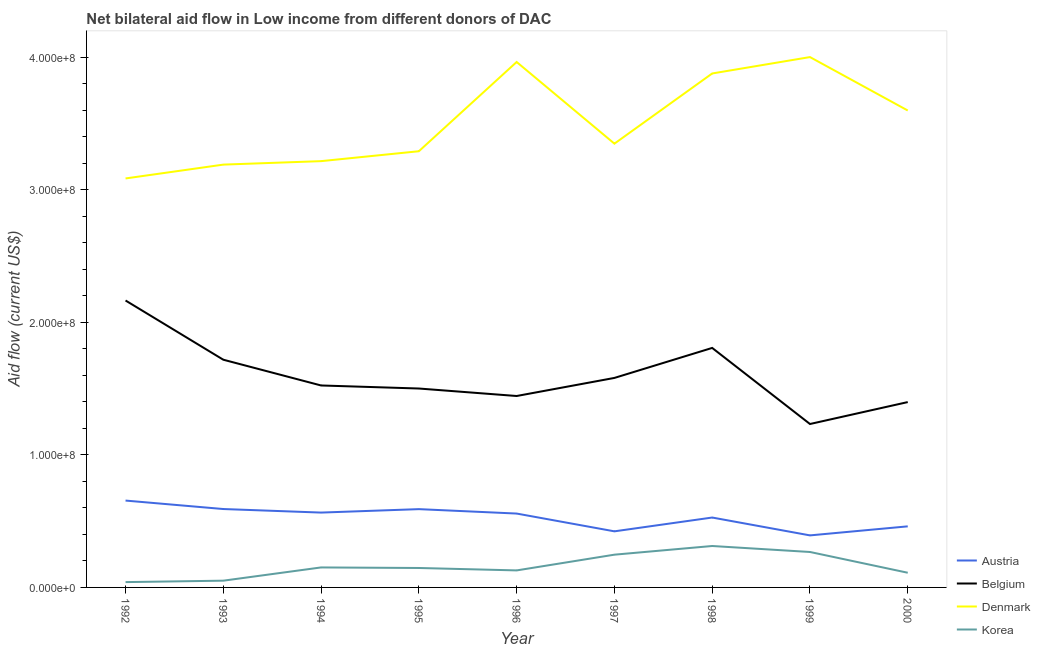Does the line corresponding to amount of aid given by belgium intersect with the line corresponding to amount of aid given by korea?
Keep it short and to the point. No. What is the amount of aid given by austria in 1994?
Give a very brief answer. 5.64e+07. Across all years, what is the maximum amount of aid given by korea?
Give a very brief answer. 3.12e+07. Across all years, what is the minimum amount of aid given by denmark?
Your answer should be compact. 3.08e+08. In which year was the amount of aid given by austria maximum?
Offer a very short reply. 1992. What is the total amount of aid given by belgium in the graph?
Your response must be concise. 1.44e+09. What is the difference between the amount of aid given by korea in 1994 and that in 1995?
Provide a succinct answer. 4.20e+05. What is the difference between the amount of aid given by korea in 1993 and the amount of aid given by austria in 1996?
Ensure brevity in your answer.  -5.06e+07. What is the average amount of aid given by belgium per year?
Ensure brevity in your answer.  1.60e+08. In the year 1996, what is the difference between the amount of aid given by belgium and amount of aid given by denmark?
Your response must be concise. -2.52e+08. What is the ratio of the amount of aid given by denmark in 1992 to that in 2000?
Offer a very short reply. 0.86. What is the difference between the highest and the second highest amount of aid given by denmark?
Your response must be concise. 3.70e+06. What is the difference between the highest and the lowest amount of aid given by belgium?
Ensure brevity in your answer.  9.32e+07. Is the sum of the amount of aid given by denmark in 1992 and 1999 greater than the maximum amount of aid given by belgium across all years?
Provide a succinct answer. Yes. Is it the case that in every year, the sum of the amount of aid given by korea and amount of aid given by austria is greater than the sum of amount of aid given by belgium and amount of aid given by denmark?
Ensure brevity in your answer.  No. Does the amount of aid given by austria monotonically increase over the years?
Provide a succinct answer. No. Is the amount of aid given by korea strictly less than the amount of aid given by denmark over the years?
Offer a very short reply. Yes. Are the values on the major ticks of Y-axis written in scientific E-notation?
Ensure brevity in your answer.  Yes. Where does the legend appear in the graph?
Provide a short and direct response. Bottom right. How many legend labels are there?
Offer a very short reply. 4. How are the legend labels stacked?
Ensure brevity in your answer.  Vertical. What is the title of the graph?
Your response must be concise. Net bilateral aid flow in Low income from different donors of DAC. Does "Tracking ability" appear as one of the legend labels in the graph?
Give a very brief answer. No. What is the label or title of the X-axis?
Your answer should be compact. Year. What is the Aid flow (current US$) of Austria in 1992?
Give a very brief answer. 6.55e+07. What is the Aid flow (current US$) in Belgium in 1992?
Your answer should be very brief. 2.16e+08. What is the Aid flow (current US$) in Denmark in 1992?
Offer a very short reply. 3.08e+08. What is the Aid flow (current US$) of Korea in 1992?
Provide a short and direct response. 4.01e+06. What is the Aid flow (current US$) of Austria in 1993?
Your answer should be compact. 5.91e+07. What is the Aid flow (current US$) in Belgium in 1993?
Give a very brief answer. 1.72e+08. What is the Aid flow (current US$) of Denmark in 1993?
Your answer should be very brief. 3.19e+08. What is the Aid flow (current US$) of Korea in 1993?
Ensure brevity in your answer.  5.09e+06. What is the Aid flow (current US$) in Austria in 1994?
Your answer should be compact. 5.64e+07. What is the Aid flow (current US$) in Belgium in 1994?
Make the answer very short. 1.52e+08. What is the Aid flow (current US$) in Denmark in 1994?
Give a very brief answer. 3.21e+08. What is the Aid flow (current US$) in Korea in 1994?
Provide a short and direct response. 1.51e+07. What is the Aid flow (current US$) in Austria in 1995?
Your response must be concise. 5.90e+07. What is the Aid flow (current US$) of Belgium in 1995?
Offer a terse response. 1.50e+08. What is the Aid flow (current US$) of Denmark in 1995?
Give a very brief answer. 3.29e+08. What is the Aid flow (current US$) in Korea in 1995?
Give a very brief answer. 1.47e+07. What is the Aid flow (current US$) of Austria in 1996?
Offer a terse response. 5.57e+07. What is the Aid flow (current US$) of Belgium in 1996?
Your answer should be compact. 1.44e+08. What is the Aid flow (current US$) of Denmark in 1996?
Provide a succinct answer. 3.96e+08. What is the Aid flow (current US$) of Korea in 1996?
Make the answer very short. 1.28e+07. What is the Aid flow (current US$) in Austria in 1997?
Your answer should be very brief. 4.23e+07. What is the Aid flow (current US$) of Belgium in 1997?
Offer a very short reply. 1.58e+08. What is the Aid flow (current US$) of Denmark in 1997?
Ensure brevity in your answer.  3.35e+08. What is the Aid flow (current US$) in Korea in 1997?
Your response must be concise. 2.47e+07. What is the Aid flow (current US$) in Austria in 1998?
Provide a short and direct response. 5.27e+07. What is the Aid flow (current US$) in Belgium in 1998?
Offer a very short reply. 1.81e+08. What is the Aid flow (current US$) in Denmark in 1998?
Your answer should be very brief. 3.88e+08. What is the Aid flow (current US$) of Korea in 1998?
Your response must be concise. 3.12e+07. What is the Aid flow (current US$) in Austria in 1999?
Offer a terse response. 3.92e+07. What is the Aid flow (current US$) of Belgium in 1999?
Make the answer very short. 1.23e+08. What is the Aid flow (current US$) in Denmark in 1999?
Your response must be concise. 4.00e+08. What is the Aid flow (current US$) of Korea in 1999?
Give a very brief answer. 2.67e+07. What is the Aid flow (current US$) of Austria in 2000?
Give a very brief answer. 4.61e+07. What is the Aid flow (current US$) in Belgium in 2000?
Your response must be concise. 1.40e+08. What is the Aid flow (current US$) of Denmark in 2000?
Ensure brevity in your answer.  3.60e+08. What is the Aid flow (current US$) of Korea in 2000?
Your response must be concise. 1.11e+07. Across all years, what is the maximum Aid flow (current US$) of Austria?
Provide a short and direct response. 6.55e+07. Across all years, what is the maximum Aid flow (current US$) in Belgium?
Give a very brief answer. 2.16e+08. Across all years, what is the maximum Aid flow (current US$) of Denmark?
Offer a very short reply. 4.00e+08. Across all years, what is the maximum Aid flow (current US$) of Korea?
Your response must be concise. 3.12e+07. Across all years, what is the minimum Aid flow (current US$) of Austria?
Give a very brief answer. 3.92e+07. Across all years, what is the minimum Aid flow (current US$) in Belgium?
Give a very brief answer. 1.23e+08. Across all years, what is the minimum Aid flow (current US$) in Denmark?
Offer a terse response. 3.08e+08. Across all years, what is the minimum Aid flow (current US$) in Korea?
Offer a terse response. 4.01e+06. What is the total Aid flow (current US$) of Austria in the graph?
Your answer should be very brief. 4.76e+08. What is the total Aid flow (current US$) in Belgium in the graph?
Your answer should be compact. 1.44e+09. What is the total Aid flow (current US$) in Denmark in the graph?
Provide a succinct answer. 3.16e+09. What is the total Aid flow (current US$) in Korea in the graph?
Make the answer very short. 1.45e+08. What is the difference between the Aid flow (current US$) of Austria in 1992 and that in 1993?
Give a very brief answer. 6.38e+06. What is the difference between the Aid flow (current US$) of Belgium in 1992 and that in 1993?
Give a very brief answer. 4.47e+07. What is the difference between the Aid flow (current US$) of Denmark in 1992 and that in 1993?
Make the answer very short. -1.04e+07. What is the difference between the Aid flow (current US$) of Korea in 1992 and that in 1993?
Make the answer very short. -1.08e+06. What is the difference between the Aid flow (current US$) of Austria in 1992 and that in 1994?
Your answer should be compact. 9.05e+06. What is the difference between the Aid flow (current US$) in Belgium in 1992 and that in 1994?
Provide a short and direct response. 6.41e+07. What is the difference between the Aid flow (current US$) in Denmark in 1992 and that in 1994?
Offer a terse response. -1.30e+07. What is the difference between the Aid flow (current US$) of Korea in 1992 and that in 1994?
Offer a very short reply. -1.11e+07. What is the difference between the Aid flow (current US$) in Austria in 1992 and that in 1995?
Offer a terse response. 6.46e+06. What is the difference between the Aid flow (current US$) of Belgium in 1992 and that in 1995?
Provide a succinct answer. 6.64e+07. What is the difference between the Aid flow (current US$) in Denmark in 1992 and that in 1995?
Keep it short and to the point. -2.05e+07. What is the difference between the Aid flow (current US$) of Korea in 1992 and that in 1995?
Make the answer very short. -1.06e+07. What is the difference between the Aid flow (current US$) in Austria in 1992 and that in 1996?
Give a very brief answer. 9.79e+06. What is the difference between the Aid flow (current US$) in Belgium in 1992 and that in 1996?
Offer a terse response. 7.20e+07. What is the difference between the Aid flow (current US$) of Denmark in 1992 and that in 1996?
Your response must be concise. -8.78e+07. What is the difference between the Aid flow (current US$) of Korea in 1992 and that in 1996?
Ensure brevity in your answer.  -8.82e+06. What is the difference between the Aid flow (current US$) of Austria in 1992 and that in 1997?
Your answer should be compact. 2.32e+07. What is the difference between the Aid flow (current US$) of Belgium in 1992 and that in 1997?
Provide a succinct answer. 5.84e+07. What is the difference between the Aid flow (current US$) in Denmark in 1992 and that in 1997?
Your response must be concise. -2.62e+07. What is the difference between the Aid flow (current US$) in Korea in 1992 and that in 1997?
Keep it short and to the point. -2.07e+07. What is the difference between the Aid flow (current US$) in Austria in 1992 and that in 1998?
Your response must be concise. 1.28e+07. What is the difference between the Aid flow (current US$) of Belgium in 1992 and that in 1998?
Keep it short and to the point. 3.58e+07. What is the difference between the Aid flow (current US$) of Denmark in 1992 and that in 1998?
Give a very brief answer. -7.92e+07. What is the difference between the Aid flow (current US$) of Korea in 1992 and that in 1998?
Give a very brief answer. -2.72e+07. What is the difference between the Aid flow (current US$) in Austria in 1992 and that in 1999?
Your response must be concise. 2.63e+07. What is the difference between the Aid flow (current US$) of Belgium in 1992 and that in 1999?
Offer a terse response. 9.32e+07. What is the difference between the Aid flow (current US$) of Denmark in 1992 and that in 1999?
Provide a short and direct response. -9.15e+07. What is the difference between the Aid flow (current US$) in Korea in 1992 and that in 1999?
Make the answer very short. -2.27e+07. What is the difference between the Aid flow (current US$) in Austria in 1992 and that in 2000?
Keep it short and to the point. 1.94e+07. What is the difference between the Aid flow (current US$) of Belgium in 1992 and that in 2000?
Your answer should be very brief. 7.66e+07. What is the difference between the Aid flow (current US$) in Denmark in 1992 and that in 2000?
Provide a succinct answer. -5.12e+07. What is the difference between the Aid flow (current US$) in Korea in 1992 and that in 2000?
Your answer should be very brief. -7.06e+06. What is the difference between the Aid flow (current US$) of Austria in 1993 and that in 1994?
Your answer should be compact. 2.67e+06. What is the difference between the Aid flow (current US$) of Belgium in 1993 and that in 1994?
Offer a terse response. 1.94e+07. What is the difference between the Aid flow (current US$) in Denmark in 1993 and that in 1994?
Provide a succinct answer. -2.62e+06. What is the difference between the Aid flow (current US$) of Korea in 1993 and that in 1994?
Provide a succinct answer. -9.99e+06. What is the difference between the Aid flow (current US$) of Belgium in 1993 and that in 1995?
Offer a very short reply. 2.17e+07. What is the difference between the Aid flow (current US$) of Denmark in 1993 and that in 1995?
Your answer should be compact. -1.01e+07. What is the difference between the Aid flow (current US$) of Korea in 1993 and that in 1995?
Offer a very short reply. -9.57e+06. What is the difference between the Aid flow (current US$) in Austria in 1993 and that in 1996?
Give a very brief answer. 3.41e+06. What is the difference between the Aid flow (current US$) in Belgium in 1993 and that in 1996?
Keep it short and to the point. 2.74e+07. What is the difference between the Aid flow (current US$) in Denmark in 1993 and that in 1996?
Your answer should be very brief. -7.74e+07. What is the difference between the Aid flow (current US$) of Korea in 1993 and that in 1996?
Offer a terse response. -7.74e+06. What is the difference between the Aid flow (current US$) of Austria in 1993 and that in 1997?
Offer a very short reply. 1.68e+07. What is the difference between the Aid flow (current US$) of Belgium in 1993 and that in 1997?
Offer a terse response. 1.37e+07. What is the difference between the Aid flow (current US$) of Denmark in 1993 and that in 1997?
Make the answer very short. -1.58e+07. What is the difference between the Aid flow (current US$) in Korea in 1993 and that in 1997?
Provide a succinct answer. -1.96e+07. What is the difference between the Aid flow (current US$) of Austria in 1993 and that in 1998?
Ensure brevity in your answer.  6.41e+06. What is the difference between the Aid flow (current US$) in Belgium in 1993 and that in 1998?
Offer a very short reply. -8.90e+06. What is the difference between the Aid flow (current US$) in Denmark in 1993 and that in 1998?
Your answer should be very brief. -6.87e+07. What is the difference between the Aid flow (current US$) of Korea in 1993 and that in 1998?
Offer a very short reply. -2.62e+07. What is the difference between the Aid flow (current US$) of Austria in 1993 and that in 1999?
Make the answer very short. 1.99e+07. What is the difference between the Aid flow (current US$) in Belgium in 1993 and that in 1999?
Offer a terse response. 4.85e+07. What is the difference between the Aid flow (current US$) of Denmark in 1993 and that in 1999?
Give a very brief answer. -8.11e+07. What is the difference between the Aid flow (current US$) in Korea in 1993 and that in 1999?
Provide a succinct answer. -2.16e+07. What is the difference between the Aid flow (current US$) of Austria in 1993 and that in 2000?
Make the answer very short. 1.31e+07. What is the difference between the Aid flow (current US$) of Belgium in 1993 and that in 2000?
Provide a short and direct response. 3.20e+07. What is the difference between the Aid flow (current US$) in Denmark in 1993 and that in 2000?
Your answer should be compact. -4.08e+07. What is the difference between the Aid flow (current US$) in Korea in 1993 and that in 2000?
Offer a very short reply. -5.98e+06. What is the difference between the Aid flow (current US$) in Austria in 1994 and that in 1995?
Your answer should be compact. -2.59e+06. What is the difference between the Aid flow (current US$) in Belgium in 1994 and that in 1995?
Offer a terse response. 2.29e+06. What is the difference between the Aid flow (current US$) of Denmark in 1994 and that in 1995?
Give a very brief answer. -7.47e+06. What is the difference between the Aid flow (current US$) in Austria in 1994 and that in 1996?
Make the answer very short. 7.40e+05. What is the difference between the Aid flow (current US$) of Belgium in 1994 and that in 1996?
Offer a very short reply. 7.94e+06. What is the difference between the Aid flow (current US$) in Denmark in 1994 and that in 1996?
Your response must be concise. -7.48e+07. What is the difference between the Aid flow (current US$) of Korea in 1994 and that in 1996?
Give a very brief answer. 2.25e+06. What is the difference between the Aid flow (current US$) in Austria in 1994 and that in 1997?
Your response must be concise. 1.42e+07. What is the difference between the Aid flow (current US$) of Belgium in 1994 and that in 1997?
Make the answer very short. -5.70e+06. What is the difference between the Aid flow (current US$) in Denmark in 1994 and that in 1997?
Your answer should be compact. -1.32e+07. What is the difference between the Aid flow (current US$) in Korea in 1994 and that in 1997?
Your response must be concise. -9.62e+06. What is the difference between the Aid flow (current US$) of Austria in 1994 and that in 1998?
Provide a short and direct response. 3.74e+06. What is the difference between the Aid flow (current US$) of Belgium in 1994 and that in 1998?
Your answer should be compact. -2.83e+07. What is the difference between the Aid flow (current US$) of Denmark in 1994 and that in 1998?
Make the answer very short. -6.61e+07. What is the difference between the Aid flow (current US$) of Korea in 1994 and that in 1998?
Your answer should be compact. -1.62e+07. What is the difference between the Aid flow (current US$) of Austria in 1994 and that in 1999?
Keep it short and to the point. 1.72e+07. What is the difference between the Aid flow (current US$) in Belgium in 1994 and that in 1999?
Offer a terse response. 2.91e+07. What is the difference between the Aid flow (current US$) of Denmark in 1994 and that in 1999?
Your answer should be compact. -7.85e+07. What is the difference between the Aid flow (current US$) of Korea in 1994 and that in 1999?
Your response must be concise. -1.16e+07. What is the difference between the Aid flow (current US$) in Austria in 1994 and that in 2000?
Give a very brief answer. 1.04e+07. What is the difference between the Aid flow (current US$) in Belgium in 1994 and that in 2000?
Offer a very short reply. 1.25e+07. What is the difference between the Aid flow (current US$) in Denmark in 1994 and that in 2000?
Offer a terse response. -3.82e+07. What is the difference between the Aid flow (current US$) in Korea in 1994 and that in 2000?
Keep it short and to the point. 4.01e+06. What is the difference between the Aid flow (current US$) in Austria in 1995 and that in 1996?
Give a very brief answer. 3.33e+06. What is the difference between the Aid flow (current US$) in Belgium in 1995 and that in 1996?
Keep it short and to the point. 5.65e+06. What is the difference between the Aid flow (current US$) of Denmark in 1995 and that in 1996?
Provide a short and direct response. -6.73e+07. What is the difference between the Aid flow (current US$) of Korea in 1995 and that in 1996?
Provide a succinct answer. 1.83e+06. What is the difference between the Aid flow (current US$) of Austria in 1995 and that in 1997?
Your answer should be very brief. 1.67e+07. What is the difference between the Aid flow (current US$) of Belgium in 1995 and that in 1997?
Provide a succinct answer. -7.99e+06. What is the difference between the Aid flow (current US$) in Denmark in 1995 and that in 1997?
Provide a succinct answer. -5.72e+06. What is the difference between the Aid flow (current US$) in Korea in 1995 and that in 1997?
Ensure brevity in your answer.  -1.00e+07. What is the difference between the Aid flow (current US$) of Austria in 1995 and that in 1998?
Provide a short and direct response. 6.33e+06. What is the difference between the Aid flow (current US$) of Belgium in 1995 and that in 1998?
Make the answer very short. -3.06e+07. What is the difference between the Aid flow (current US$) in Denmark in 1995 and that in 1998?
Ensure brevity in your answer.  -5.86e+07. What is the difference between the Aid flow (current US$) of Korea in 1995 and that in 1998?
Give a very brief answer. -1.66e+07. What is the difference between the Aid flow (current US$) of Austria in 1995 and that in 1999?
Offer a terse response. 1.98e+07. What is the difference between the Aid flow (current US$) of Belgium in 1995 and that in 1999?
Give a very brief answer. 2.68e+07. What is the difference between the Aid flow (current US$) in Denmark in 1995 and that in 1999?
Your answer should be compact. -7.10e+07. What is the difference between the Aid flow (current US$) in Korea in 1995 and that in 1999?
Provide a short and direct response. -1.21e+07. What is the difference between the Aid flow (current US$) in Austria in 1995 and that in 2000?
Provide a succinct answer. 1.30e+07. What is the difference between the Aid flow (current US$) in Belgium in 1995 and that in 2000?
Keep it short and to the point. 1.02e+07. What is the difference between the Aid flow (current US$) in Denmark in 1995 and that in 2000?
Your answer should be compact. -3.07e+07. What is the difference between the Aid flow (current US$) of Korea in 1995 and that in 2000?
Make the answer very short. 3.59e+06. What is the difference between the Aid flow (current US$) in Austria in 1996 and that in 1997?
Give a very brief answer. 1.34e+07. What is the difference between the Aid flow (current US$) of Belgium in 1996 and that in 1997?
Make the answer very short. -1.36e+07. What is the difference between the Aid flow (current US$) of Denmark in 1996 and that in 1997?
Offer a very short reply. 6.16e+07. What is the difference between the Aid flow (current US$) in Korea in 1996 and that in 1997?
Your answer should be compact. -1.19e+07. What is the difference between the Aid flow (current US$) of Belgium in 1996 and that in 1998?
Your response must be concise. -3.63e+07. What is the difference between the Aid flow (current US$) of Denmark in 1996 and that in 1998?
Provide a short and direct response. 8.66e+06. What is the difference between the Aid flow (current US$) of Korea in 1996 and that in 1998?
Keep it short and to the point. -1.84e+07. What is the difference between the Aid flow (current US$) of Austria in 1996 and that in 1999?
Keep it short and to the point. 1.65e+07. What is the difference between the Aid flow (current US$) in Belgium in 1996 and that in 1999?
Offer a very short reply. 2.11e+07. What is the difference between the Aid flow (current US$) in Denmark in 1996 and that in 1999?
Keep it short and to the point. -3.70e+06. What is the difference between the Aid flow (current US$) of Korea in 1996 and that in 1999?
Make the answer very short. -1.39e+07. What is the difference between the Aid flow (current US$) in Austria in 1996 and that in 2000?
Provide a succinct answer. 9.65e+06. What is the difference between the Aid flow (current US$) of Belgium in 1996 and that in 2000?
Offer a terse response. 4.59e+06. What is the difference between the Aid flow (current US$) in Denmark in 1996 and that in 2000?
Your answer should be very brief. 3.66e+07. What is the difference between the Aid flow (current US$) of Korea in 1996 and that in 2000?
Keep it short and to the point. 1.76e+06. What is the difference between the Aid flow (current US$) in Austria in 1997 and that in 1998?
Offer a terse response. -1.04e+07. What is the difference between the Aid flow (current US$) of Belgium in 1997 and that in 1998?
Provide a short and direct response. -2.26e+07. What is the difference between the Aid flow (current US$) of Denmark in 1997 and that in 1998?
Your answer should be very brief. -5.29e+07. What is the difference between the Aid flow (current US$) in Korea in 1997 and that in 1998?
Offer a terse response. -6.54e+06. What is the difference between the Aid flow (current US$) in Austria in 1997 and that in 1999?
Provide a succinct answer. 3.06e+06. What is the difference between the Aid flow (current US$) of Belgium in 1997 and that in 1999?
Make the answer very short. 3.48e+07. What is the difference between the Aid flow (current US$) in Denmark in 1997 and that in 1999?
Provide a succinct answer. -6.53e+07. What is the difference between the Aid flow (current US$) in Korea in 1997 and that in 1999?
Offer a very short reply. -2.03e+06. What is the difference between the Aid flow (current US$) in Austria in 1997 and that in 2000?
Keep it short and to the point. -3.76e+06. What is the difference between the Aid flow (current US$) of Belgium in 1997 and that in 2000?
Provide a succinct answer. 1.82e+07. What is the difference between the Aid flow (current US$) of Denmark in 1997 and that in 2000?
Your answer should be compact. -2.50e+07. What is the difference between the Aid flow (current US$) of Korea in 1997 and that in 2000?
Give a very brief answer. 1.36e+07. What is the difference between the Aid flow (current US$) in Austria in 1998 and that in 1999?
Make the answer very short. 1.35e+07. What is the difference between the Aid flow (current US$) of Belgium in 1998 and that in 1999?
Ensure brevity in your answer.  5.74e+07. What is the difference between the Aid flow (current US$) of Denmark in 1998 and that in 1999?
Give a very brief answer. -1.24e+07. What is the difference between the Aid flow (current US$) of Korea in 1998 and that in 1999?
Give a very brief answer. 4.51e+06. What is the difference between the Aid flow (current US$) of Austria in 1998 and that in 2000?
Offer a very short reply. 6.65e+06. What is the difference between the Aid flow (current US$) of Belgium in 1998 and that in 2000?
Your answer should be compact. 4.08e+07. What is the difference between the Aid flow (current US$) of Denmark in 1998 and that in 2000?
Provide a short and direct response. 2.79e+07. What is the difference between the Aid flow (current US$) of Korea in 1998 and that in 2000?
Give a very brief answer. 2.02e+07. What is the difference between the Aid flow (current US$) in Austria in 1999 and that in 2000?
Offer a very short reply. -6.82e+06. What is the difference between the Aid flow (current US$) of Belgium in 1999 and that in 2000?
Offer a terse response. -1.65e+07. What is the difference between the Aid flow (current US$) in Denmark in 1999 and that in 2000?
Your answer should be compact. 4.03e+07. What is the difference between the Aid flow (current US$) of Korea in 1999 and that in 2000?
Offer a terse response. 1.57e+07. What is the difference between the Aid flow (current US$) of Austria in 1992 and the Aid flow (current US$) of Belgium in 1993?
Keep it short and to the point. -1.06e+08. What is the difference between the Aid flow (current US$) in Austria in 1992 and the Aid flow (current US$) in Denmark in 1993?
Keep it short and to the point. -2.53e+08. What is the difference between the Aid flow (current US$) in Austria in 1992 and the Aid flow (current US$) in Korea in 1993?
Give a very brief answer. 6.04e+07. What is the difference between the Aid flow (current US$) in Belgium in 1992 and the Aid flow (current US$) in Denmark in 1993?
Offer a very short reply. -1.02e+08. What is the difference between the Aid flow (current US$) in Belgium in 1992 and the Aid flow (current US$) in Korea in 1993?
Make the answer very short. 2.11e+08. What is the difference between the Aid flow (current US$) of Denmark in 1992 and the Aid flow (current US$) of Korea in 1993?
Provide a succinct answer. 3.03e+08. What is the difference between the Aid flow (current US$) in Austria in 1992 and the Aid flow (current US$) in Belgium in 1994?
Your answer should be compact. -8.68e+07. What is the difference between the Aid flow (current US$) of Austria in 1992 and the Aid flow (current US$) of Denmark in 1994?
Keep it short and to the point. -2.56e+08. What is the difference between the Aid flow (current US$) of Austria in 1992 and the Aid flow (current US$) of Korea in 1994?
Provide a short and direct response. 5.04e+07. What is the difference between the Aid flow (current US$) of Belgium in 1992 and the Aid flow (current US$) of Denmark in 1994?
Keep it short and to the point. -1.05e+08. What is the difference between the Aid flow (current US$) in Belgium in 1992 and the Aid flow (current US$) in Korea in 1994?
Provide a succinct answer. 2.01e+08. What is the difference between the Aid flow (current US$) in Denmark in 1992 and the Aid flow (current US$) in Korea in 1994?
Ensure brevity in your answer.  2.93e+08. What is the difference between the Aid flow (current US$) in Austria in 1992 and the Aid flow (current US$) in Belgium in 1995?
Keep it short and to the point. -8.45e+07. What is the difference between the Aid flow (current US$) of Austria in 1992 and the Aid flow (current US$) of Denmark in 1995?
Your response must be concise. -2.63e+08. What is the difference between the Aid flow (current US$) of Austria in 1992 and the Aid flow (current US$) of Korea in 1995?
Ensure brevity in your answer.  5.08e+07. What is the difference between the Aid flow (current US$) of Belgium in 1992 and the Aid flow (current US$) of Denmark in 1995?
Keep it short and to the point. -1.13e+08. What is the difference between the Aid flow (current US$) in Belgium in 1992 and the Aid flow (current US$) in Korea in 1995?
Keep it short and to the point. 2.02e+08. What is the difference between the Aid flow (current US$) in Denmark in 1992 and the Aid flow (current US$) in Korea in 1995?
Make the answer very short. 2.94e+08. What is the difference between the Aid flow (current US$) in Austria in 1992 and the Aid flow (current US$) in Belgium in 1996?
Your answer should be very brief. -7.89e+07. What is the difference between the Aid flow (current US$) in Austria in 1992 and the Aid flow (current US$) in Denmark in 1996?
Make the answer very short. -3.31e+08. What is the difference between the Aid flow (current US$) of Austria in 1992 and the Aid flow (current US$) of Korea in 1996?
Your response must be concise. 5.27e+07. What is the difference between the Aid flow (current US$) of Belgium in 1992 and the Aid flow (current US$) of Denmark in 1996?
Give a very brief answer. -1.80e+08. What is the difference between the Aid flow (current US$) in Belgium in 1992 and the Aid flow (current US$) in Korea in 1996?
Provide a succinct answer. 2.04e+08. What is the difference between the Aid flow (current US$) of Denmark in 1992 and the Aid flow (current US$) of Korea in 1996?
Ensure brevity in your answer.  2.96e+08. What is the difference between the Aid flow (current US$) in Austria in 1992 and the Aid flow (current US$) in Belgium in 1997?
Offer a very short reply. -9.25e+07. What is the difference between the Aid flow (current US$) in Austria in 1992 and the Aid flow (current US$) in Denmark in 1997?
Give a very brief answer. -2.69e+08. What is the difference between the Aid flow (current US$) of Austria in 1992 and the Aid flow (current US$) of Korea in 1997?
Offer a very short reply. 4.08e+07. What is the difference between the Aid flow (current US$) of Belgium in 1992 and the Aid flow (current US$) of Denmark in 1997?
Keep it short and to the point. -1.18e+08. What is the difference between the Aid flow (current US$) in Belgium in 1992 and the Aid flow (current US$) in Korea in 1997?
Give a very brief answer. 1.92e+08. What is the difference between the Aid flow (current US$) of Denmark in 1992 and the Aid flow (current US$) of Korea in 1997?
Keep it short and to the point. 2.84e+08. What is the difference between the Aid flow (current US$) in Austria in 1992 and the Aid flow (current US$) in Belgium in 1998?
Offer a terse response. -1.15e+08. What is the difference between the Aid flow (current US$) in Austria in 1992 and the Aid flow (current US$) in Denmark in 1998?
Your response must be concise. -3.22e+08. What is the difference between the Aid flow (current US$) of Austria in 1992 and the Aid flow (current US$) of Korea in 1998?
Your response must be concise. 3.43e+07. What is the difference between the Aid flow (current US$) of Belgium in 1992 and the Aid flow (current US$) of Denmark in 1998?
Offer a very short reply. -1.71e+08. What is the difference between the Aid flow (current US$) of Belgium in 1992 and the Aid flow (current US$) of Korea in 1998?
Give a very brief answer. 1.85e+08. What is the difference between the Aid flow (current US$) of Denmark in 1992 and the Aid flow (current US$) of Korea in 1998?
Provide a short and direct response. 2.77e+08. What is the difference between the Aid flow (current US$) in Austria in 1992 and the Aid flow (current US$) in Belgium in 1999?
Keep it short and to the point. -5.77e+07. What is the difference between the Aid flow (current US$) in Austria in 1992 and the Aid flow (current US$) in Denmark in 1999?
Give a very brief answer. -3.34e+08. What is the difference between the Aid flow (current US$) in Austria in 1992 and the Aid flow (current US$) in Korea in 1999?
Give a very brief answer. 3.88e+07. What is the difference between the Aid flow (current US$) of Belgium in 1992 and the Aid flow (current US$) of Denmark in 1999?
Give a very brief answer. -1.84e+08. What is the difference between the Aid flow (current US$) in Belgium in 1992 and the Aid flow (current US$) in Korea in 1999?
Provide a short and direct response. 1.90e+08. What is the difference between the Aid flow (current US$) of Denmark in 1992 and the Aid flow (current US$) of Korea in 1999?
Ensure brevity in your answer.  2.82e+08. What is the difference between the Aid flow (current US$) of Austria in 1992 and the Aid flow (current US$) of Belgium in 2000?
Your answer should be very brief. -7.43e+07. What is the difference between the Aid flow (current US$) in Austria in 1992 and the Aid flow (current US$) in Denmark in 2000?
Your answer should be compact. -2.94e+08. What is the difference between the Aid flow (current US$) in Austria in 1992 and the Aid flow (current US$) in Korea in 2000?
Provide a short and direct response. 5.44e+07. What is the difference between the Aid flow (current US$) in Belgium in 1992 and the Aid flow (current US$) in Denmark in 2000?
Offer a terse response. -1.43e+08. What is the difference between the Aid flow (current US$) of Belgium in 1992 and the Aid flow (current US$) of Korea in 2000?
Provide a succinct answer. 2.05e+08. What is the difference between the Aid flow (current US$) of Denmark in 1992 and the Aid flow (current US$) of Korea in 2000?
Provide a short and direct response. 2.97e+08. What is the difference between the Aid flow (current US$) of Austria in 1993 and the Aid flow (current US$) of Belgium in 1994?
Your answer should be very brief. -9.32e+07. What is the difference between the Aid flow (current US$) of Austria in 1993 and the Aid flow (current US$) of Denmark in 1994?
Provide a succinct answer. -2.62e+08. What is the difference between the Aid flow (current US$) of Austria in 1993 and the Aid flow (current US$) of Korea in 1994?
Provide a succinct answer. 4.40e+07. What is the difference between the Aid flow (current US$) of Belgium in 1993 and the Aid flow (current US$) of Denmark in 1994?
Your answer should be very brief. -1.50e+08. What is the difference between the Aid flow (current US$) of Belgium in 1993 and the Aid flow (current US$) of Korea in 1994?
Your answer should be very brief. 1.57e+08. What is the difference between the Aid flow (current US$) of Denmark in 1993 and the Aid flow (current US$) of Korea in 1994?
Give a very brief answer. 3.04e+08. What is the difference between the Aid flow (current US$) of Austria in 1993 and the Aid flow (current US$) of Belgium in 1995?
Keep it short and to the point. -9.09e+07. What is the difference between the Aid flow (current US$) in Austria in 1993 and the Aid flow (current US$) in Denmark in 1995?
Your answer should be compact. -2.70e+08. What is the difference between the Aid flow (current US$) in Austria in 1993 and the Aid flow (current US$) in Korea in 1995?
Make the answer very short. 4.45e+07. What is the difference between the Aid flow (current US$) of Belgium in 1993 and the Aid flow (current US$) of Denmark in 1995?
Keep it short and to the point. -1.57e+08. What is the difference between the Aid flow (current US$) of Belgium in 1993 and the Aid flow (current US$) of Korea in 1995?
Keep it short and to the point. 1.57e+08. What is the difference between the Aid flow (current US$) in Denmark in 1993 and the Aid flow (current US$) in Korea in 1995?
Make the answer very short. 3.04e+08. What is the difference between the Aid flow (current US$) in Austria in 1993 and the Aid flow (current US$) in Belgium in 1996?
Offer a terse response. -8.52e+07. What is the difference between the Aid flow (current US$) of Austria in 1993 and the Aid flow (current US$) of Denmark in 1996?
Your answer should be very brief. -3.37e+08. What is the difference between the Aid flow (current US$) of Austria in 1993 and the Aid flow (current US$) of Korea in 1996?
Make the answer very short. 4.63e+07. What is the difference between the Aid flow (current US$) in Belgium in 1993 and the Aid flow (current US$) in Denmark in 1996?
Your answer should be very brief. -2.25e+08. What is the difference between the Aid flow (current US$) in Belgium in 1993 and the Aid flow (current US$) in Korea in 1996?
Offer a terse response. 1.59e+08. What is the difference between the Aid flow (current US$) of Denmark in 1993 and the Aid flow (current US$) of Korea in 1996?
Offer a very short reply. 3.06e+08. What is the difference between the Aid flow (current US$) of Austria in 1993 and the Aid flow (current US$) of Belgium in 1997?
Provide a short and direct response. -9.89e+07. What is the difference between the Aid flow (current US$) in Austria in 1993 and the Aid flow (current US$) in Denmark in 1997?
Make the answer very short. -2.76e+08. What is the difference between the Aid flow (current US$) of Austria in 1993 and the Aid flow (current US$) of Korea in 1997?
Make the answer very short. 3.44e+07. What is the difference between the Aid flow (current US$) in Belgium in 1993 and the Aid flow (current US$) in Denmark in 1997?
Offer a very short reply. -1.63e+08. What is the difference between the Aid flow (current US$) in Belgium in 1993 and the Aid flow (current US$) in Korea in 1997?
Your answer should be very brief. 1.47e+08. What is the difference between the Aid flow (current US$) in Denmark in 1993 and the Aid flow (current US$) in Korea in 1997?
Offer a terse response. 2.94e+08. What is the difference between the Aid flow (current US$) of Austria in 1993 and the Aid flow (current US$) of Belgium in 1998?
Provide a short and direct response. -1.22e+08. What is the difference between the Aid flow (current US$) of Austria in 1993 and the Aid flow (current US$) of Denmark in 1998?
Provide a succinct answer. -3.28e+08. What is the difference between the Aid flow (current US$) in Austria in 1993 and the Aid flow (current US$) in Korea in 1998?
Your answer should be compact. 2.79e+07. What is the difference between the Aid flow (current US$) of Belgium in 1993 and the Aid flow (current US$) of Denmark in 1998?
Provide a short and direct response. -2.16e+08. What is the difference between the Aid flow (current US$) of Belgium in 1993 and the Aid flow (current US$) of Korea in 1998?
Your answer should be compact. 1.40e+08. What is the difference between the Aid flow (current US$) of Denmark in 1993 and the Aid flow (current US$) of Korea in 1998?
Give a very brief answer. 2.88e+08. What is the difference between the Aid flow (current US$) in Austria in 1993 and the Aid flow (current US$) in Belgium in 1999?
Make the answer very short. -6.41e+07. What is the difference between the Aid flow (current US$) in Austria in 1993 and the Aid flow (current US$) in Denmark in 1999?
Offer a very short reply. -3.41e+08. What is the difference between the Aid flow (current US$) of Austria in 1993 and the Aid flow (current US$) of Korea in 1999?
Your response must be concise. 3.24e+07. What is the difference between the Aid flow (current US$) in Belgium in 1993 and the Aid flow (current US$) in Denmark in 1999?
Offer a very short reply. -2.28e+08. What is the difference between the Aid flow (current US$) in Belgium in 1993 and the Aid flow (current US$) in Korea in 1999?
Ensure brevity in your answer.  1.45e+08. What is the difference between the Aid flow (current US$) of Denmark in 1993 and the Aid flow (current US$) of Korea in 1999?
Offer a terse response. 2.92e+08. What is the difference between the Aid flow (current US$) of Austria in 1993 and the Aid flow (current US$) of Belgium in 2000?
Provide a short and direct response. -8.06e+07. What is the difference between the Aid flow (current US$) of Austria in 1993 and the Aid flow (current US$) of Denmark in 2000?
Make the answer very short. -3.01e+08. What is the difference between the Aid flow (current US$) in Austria in 1993 and the Aid flow (current US$) in Korea in 2000?
Make the answer very short. 4.80e+07. What is the difference between the Aid flow (current US$) in Belgium in 1993 and the Aid flow (current US$) in Denmark in 2000?
Offer a terse response. -1.88e+08. What is the difference between the Aid flow (current US$) of Belgium in 1993 and the Aid flow (current US$) of Korea in 2000?
Your response must be concise. 1.61e+08. What is the difference between the Aid flow (current US$) of Denmark in 1993 and the Aid flow (current US$) of Korea in 2000?
Give a very brief answer. 3.08e+08. What is the difference between the Aid flow (current US$) in Austria in 1994 and the Aid flow (current US$) in Belgium in 1995?
Make the answer very short. -9.36e+07. What is the difference between the Aid flow (current US$) of Austria in 1994 and the Aid flow (current US$) of Denmark in 1995?
Your answer should be compact. -2.72e+08. What is the difference between the Aid flow (current US$) in Austria in 1994 and the Aid flow (current US$) in Korea in 1995?
Your answer should be very brief. 4.18e+07. What is the difference between the Aid flow (current US$) in Belgium in 1994 and the Aid flow (current US$) in Denmark in 1995?
Provide a succinct answer. -1.77e+08. What is the difference between the Aid flow (current US$) in Belgium in 1994 and the Aid flow (current US$) in Korea in 1995?
Offer a very short reply. 1.38e+08. What is the difference between the Aid flow (current US$) of Denmark in 1994 and the Aid flow (current US$) of Korea in 1995?
Your answer should be compact. 3.07e+08. What is the difference between the Aid flow (current US$) in Austria in 1994 and the Aid flow (current US$) in Belgium in 1996?
Your answer should be compact. -8.79e+07. What is the difference between the Aid flow (current US$) of Austria in 1994 and the Aid flow (current US$) of Denmark in 1996?
Make the answer very short. -3.40e+08. What is the difference between the Aid flow (current US$) of Austria in 1994 and the Aid flow (current US$) of Korea in 1996?
Provide a succinct answer. 4.36e+07. What is the difference between the Aid flow (current US$) of Belgium in 1994 and the Aid flow (current US$) of Denmark in 1996?
Your answer should be compact. -2.44e+08. What is the difference between the Aid flow (current US$) in Belgium in 1994 and the Aid flow (current US$) in Korea in 1996?
Offer a very short reply. 1.39e+08. What is the difference between the Aid flow (current US$) in Denmark in 1994 and the Aid flow (current US$) in Korea in 1996?
Provide a short and direct response. 3.09e+08. What is the difference between the Aid flow (current US$) of Austria in 1994 and the Aid flow (current US$) of Belgium in 1997?
Offer a very short reply. -1.02e+08. What is the difference between the Aid flow (current US$) of Austria in 1994 and the Aid flow (current US$) of Denmark in 1997?
Offer a terse response. -2.78e+08. What is the difference between the Aid flow (current US$) of Austria in 1994 and the Aid flow (current US$) of Korea in 1997?
Offer a very short reply. 3.18e+07. What is the difference between the Aid flow (current US$) in Belgium in 1994 and the Aid flow (current US$) in Denmark in 1997?
Offer a terse response. -1.82e+08. What is the difference between the Aid flow (current US$) in Belgium in 1994 and the Aid flow (current US$) in Korea in 1997?
Provide a succinct answer. 1.28e+08. What is the difference between the Aid flow (current US$) in Denmark in 1994 and the Aid flow (current US$) in Korea in 1997?
Your answer should be compact. 2.97e+08. What is the difference between the Aid flow (current US$) of Austria in 1994 and the Aid flow (current US$) of Belgium in 1998?
Offer a very short reply. -1.24e+08. What is the difference between the Aid flow (current US$) of Austria in 1994 and the Aid flow (current US$) of Denmark in 1998?
Ensure brevity in your answer.  -3.31e+08. What is the difference between the Aid flow (current US$) of Austria in 1994 and the Aid flow (current US$) of Korea in 1998?
Your answer should be compact. 2.52e+07. What is the difference between the Aid flow (current US$) in Belgium in 1994 and the Aid flow (current US$) in Denmark in 1998?
Offer a terse response. -2.35e+08. What is the difference between the Aid flow (current US$) in Belgium in 1994 and the Aid flow (current US$) in Korea in 1998?
Offer a terse response. 1.21e+08. What is the difference between the Aid flow (current US$) of Denmark in 1994 and the Aid flow (current US$) of Korea in 1998?
Your response must be concise. 2.90e+08. What is the difference between the Aid flow (current US$) of Austria in 1994 and the Aid flow (current US$) of Belgium in 1999?
Your answer should be very brief. -6.68e+07. What is the difference between the Aid flow (current US$) in Austria in 1994 and the Aid flow (current US$) in Denmark in 1999?
Keep it short and to the point. -3.44e+08. What is the difference between the Aid flow (current US$) in Austria in 1994 and the Aid flow (current US$) in Korea in 1999?
Your response must be concise. 2.97e+07. What is the difference between the Aid flow (current US$) of Belgium in 1994 and the Aid flow (current US$) of Denmark in 1999?
Provide a succinct answer. -2.48e+08. What is the difference between the Aid flow (current US$) of Belgium in 1994 and the Aid flow (current US$) of Korea in 1999?
Offer a very short reply. 1.26e+08. What is the difference between the Aid flow (current US$) in Denmark in 1994 and the Aid flow (current US$) in Korea in 1999?
Make the answer very short. 2.95e+08. What is the difference between the Aid flow (current US$) in Austria in 1994 and the Aid flow (current US$) in Belgium in 2000?
Keep it short and to the point. -8.33e+07. What is the difference between the Aid flow (current US$) in Austria in 1994 and the Aid flow (current US$) in Denmark in 2000?
Keep it short and to the point. -3.03e+08. What is the difference between the Aid flow (current US$) of Austria in 1994 and the Aid flow (current US$) of Korea in 2000?
Provide a short and direct response. 4.54e+07. What is the difference between the Aid flow (current US$) in Belgium in 1994 and the Aid flow (current US$) in Denmark in 2000?
Provide a succinct answer. -2.07e+08. What is the difference between the Aid flow (current US$) of Belgium in 1994 and the Aid flow (current US$) of Korea in 2000?
Offer a terse response. 1.41e+08. What is the difference between the Aid flow (current US$) in Denmark in 1994 and the Aid flow (current US$) in Korea in 2000?
Give a very brief answer. 3.10e+08. What is the difference between the Aid flow (current US$) in Austria in 1995 and the Aid flow (current US$) in Belgium in 1996?
Your answer should be compact. -8.53e+07. What is the difference between the Aid flow (current US$) in Austria in 1995 and the Aid flow (current US$) in Denmark in 1996?
Provide a succinct answer. -3.37e+08. What is the difference between the Aid flow (current US$) in Austria in 1995 and the Aid flow (current US$) in Korea in 1996?
Provide a succinct answer. 4.62e+07. What is the difference between the Aid flow (current US$) in Belgium in 1995 and the Aid flow (current US$) in Denmark in 1996?
Your answer should be very brief. -2.46e+08. What is the difference between the Aid flow (current US$) of Belgium in 1995 and the Aid flow (current US$) of Korea in 1996?
Make the answer very short. 1.37e+08. What is the difference between the Aid flow (current US$) of Denmark in 1995 and the Aid flow (current US$) of Korea in 1996?
Your answer should be very brief. 3.16e+08. What is the difference between the Aid flow (current US$) of Austria in 1995 and the Aid flow (current US$) of Belgium in 1997?
Provide a succinct answer. -9.90e+07. What is the difference between the Aid flow (current US$) in Austria in 1995 and the Aid flow (current US$) in Denmark in 1997?
Make the answer very short. -2.76e+08. What is the difference between the Aid flow (current US$) in Austria in 1995 and the Aid flow (current US$) in Korea in 1997?
Make the answer very short. 3.43e+07. What is the difference between the Aid flow (current US$) of Belgium in 1995 and the Aid flow (current US$) of Denmark in 1997?
Provide a succinct answer. -1.85e+08. What is the difference between the Aid flow (current US$) in Belgium in 1995 and the Aid flow (current US$) in Korea in 1997?
Provide a succinct answer. 1.25e+08. What is the difference between the Aid flow (current US$) in Denmark in 1995 and the Aid flow (current US$) in Korea in 1997?
Ensure brevity in your answer.  3.04e+08. What is the difference between the Aid flow (current US$) of Austria in 1995 and the Aid flow (current US$) of Belgium in 1998?
Offer a terse response. -1.22e+08. What is the difference between the Aid flow (current US$) in Austria in 1995 and the Aid flow (current US$) in Denmark in 1998?
Make the answer very short. -3.29e+08. What is the difference between the Aid flow (current US$) of Austria in 1995 and the Aid flow (current US$) of Korea in 1998?
Provide a short and direct response. 2.78e+07. What is the difference between the Aid flow (current US$) in Belgium in 1995 and the Aid flow (current US$) in Denmark in 1998?
Your response must be concise. -2.38e+08. What is the difference between the Aid flow (current US$) in Belgium in 1995 and the Aid flow (current US$) in Korea in 1998?
Ensure brevity in your answer.  1.19e+08. What is the difference between the Aid flow (current US$) of Denmark in 1995 and the Aid flow (current US$) of Korea in 1998?
Your answer should be compact. 2.98e+08. What is the difference between the Aid flow (current US$) in Austria in 1995 and the Aid flow (current US$) in Belgium in 1999?
Offer a very short reply. -6.42e+07. What is the difference between the Aid flow (current US$) in Austria in 1995 and the Aid flow (current US$) in Denmark in 1999?
Ensure brevity in your answer.  -3.41e+08. What is the difference between the Aid flow (current US$) of Austria in 1995 and the Aid flow (current US$) of Korea in 1999?
Give a very brief answer. 3.23e+07. What is the difference between the Aid flow (current US$) in Belgium in 1995 and the Aid flow (current US$) in Denmark in 1999?
Provide a succinct answer. -2.50e+08. What is the difference between the Aid flow (current US$) in Belgium in 1995 and the Aid flow (current US$) in Korea in 1999?
Keep it short and to the point. 1.23e+08. What is the difference between the Aid flow (current US$) of Denmark in 1995 and the Aid flow (current US$) of Korea in 1999?
Your answer should be compact. 3.02e+08. What is the difference between the Aid flow (current US$) of Austria in 1995 and the Aid flow (current US$) of Belgium in 2000?
Offer a terse response. -8.07e+07. What is the difference between the Aid flow (current US$) of Austria in 1995 and the Aid flow (current US$) of Denmark in 2000?
Your answer should be very brief. -3.01e+08. What is the difference between the Aid flow (current US$) in Austria in 1995 and the Aid flow (current US$) in Korea in 2000?
Provide a succinct answer. 4.80e+07. What is the difference between the Aid flow (current US$) of Belgium in 1995 and the Aid flow (current US$) of Denmark in 2000?
Give a very brief answer. -2.10e+08. What is the difference between the Aid flow (current US$) in Belgium in 1995 and the Aid flow (current US$) in Korea in 2000?
Make the answer very short. 1.39e+08. What is the difference between the Aid flow (current US$) in Denmark in 1995 and the Aid flow (current US$) in Korea in 2000?
Offer a terse response. 3.18e+08. What is the difference between the Aid flow (current US$) of Austria in 1996 and the Aid flow (current US$) of Belgium in 1997?
Your answer should be very brief. -1.02e+08. What is the difference between the Aid flow (current US$) in Austria in 1996 and the Aid flow (current US$) in Denmark in 1997?
Keep it short and to the point. -2.79e+08. What is the difference between the Aid flow (current US$) in Austria in 1996 and the Aid flow (current US$) in Korea in 1997?
Ensure brevity in your answer.  3.10e+07. What is the difference between the Aid flow (current US$) of Belgium in 1996 and the Aid flow (current US$) of Denmark in 1997?
Your answer should be very brief. -1.90e+08. What is the difference between the Aid flow (current US$) in Belgium in 1996 and the Aid flow (current US$) in Korea in 1997?
Ensure brevity in your answer.  1.20e+08. What is the difference between the Aid flow (current US$) of Denmark in 1996 and the Aid flow (current US$) of Korea in 1997?
Ensure brevity in your answer.  3.72e+08. What is the difference between the Aid flow (current US$) in Austria in 1996 and the Aid flow (current US$) in Belgium in 1998?
Keep it short and to the point. -1.25e+08. What is the difference between the Aid flow (current US$) in Austria in 1996 and the Aid flow (current US$) in Denmark in 1998?
Make the answer very short. -3.32e+08. What is the difference between the Aid flow (current US$) of Austria in 1996 and the Aid flow (current US$) of Korea in 1998?
Give a very brief answer. 2.45e+07. What is the difference between the Aid flow (current US$) of Belgium in 1996 and the Aid flow (current US$) of Denmark in 1998?
Make the answer very short. -2.43e+08. What is the difference between the Aid flow (current US$) of Belgium in 1996 and the Aid flow (current US$) of Korea in 1998?
Give a very brief answer. 1.13e+08. What is the difference between the Aid flow (current US$) in Denmark in 1996 and the Aid flow (current US$) in Korea in 1998?
Offer a terse response. 3.65e+08. What is the difference between the Aid flow (current US$) in Austria in 1996 and the Aid flow (current US$) in Belgium in 1999?
Your answer should be very brief. -6.75e+07. What is the difference between the Aid flow (current US$) in Austria in 1996 and the Aid flow (current US$) in Denmark in 1999?
Keep it short and to the point. -3.44e+08. What is the difference between the Aid flow (current US$) of Austria in 1996 and the Aid flow (current US$) of Korea in 1999?
Offer a terse response. 2.90e+07. What is the difference between the Aid flow (current US$) of Belgium in 1996 and the Aid flow (current US$) of Denmark in 1999?
Keep it short and to the point. -2.56e+08. What is the difference between the Aid flow (current US$) of Belgium in 1996 and the Aid flow (current US$) of Korea in 1999?
Offer a very short reply. 1.18e+08. What is the difference between the Aid flow (current US$) of Denmark in 1996 and the Aid flow (current US$) of Korea in 1999?
Your answer should be compact. 3.70e+08. What is the difference between the Aid flow (current US$) of Austria in 1996 and the Aid flow (current US$) of Belgium in 2000?
Your answer should be compact. -8.41e+07. What is the difference between the Aid flow (current US$) in Austria in 1996 and the Aid flow (current US$) in Denmark in 2000?
Offer a very short reply. -3.04e+08. What is the difference between the Aid flow (current US$) in Austria in 1996 and the Aid flow (current US$) in Korea in 2000?
Your response must be concise. 4.46e+07. What is the difference between the Aid flow (current US$) of Belgium in 1996 and the Aid flow (current US$) of Denmark in 2000?
Offer a very short reply. -2.15e+08. What is the difference between the Aid flow (current US$) in Belgium in 1996 and the Aid flow (current US$) in Korea in 2000?
Ensure brevity in your answer.  1.33e+08. What is the difference between the Aid flow (current US$) in Denmark in 1996 and the Aid flow (current US$) in Korea in 2000?
Keep it short and to the point. 3.85e+08. What is the difference between the Aid flow (current US$) in Austria in 1997 and the Aid flow (current US$) in Belgium in 1998?
Provide a succinct answer. -1.38e+08. What is the difference between the Aid flow (current US$) of Austria in 1997 and the Aid flow (current US$) of Denmark in 1998?
Your answer should be compact. -3.45e+08. What is the difference between the Aid flow (current US$) of Austria in 1997 and the Aid flow (current US$) of Korea in 1998?
Your response must be concise. 1.11e+07. What is the difference between the Aid flow (current US$) of Belgium in 1997 and the Aid flow (current US$) of Denmark in 1998?
Make the answer very short. -2.30e+08. What is the difference between the Aid flow (current US$) in Belgium in 1997 and the Aid flow (current US$) in Korea in 1998?
Provide a succinct answer. 1.27e+08. What is the difference between the Aid flow (current US$) in Denmark in 1997 and the Aid flow (current US$) in Korea in 1998?
Offer a terse response. 3.03e+08. What is the difference between the Aid flow (current US$) of Austria in 1997 and the Aid flow (current US$) of Belgium in 1999?
Give a very brief answer. -8.09e+07. What is the difference between the Aid flow (current US$) of Austria in 1997 and the Aid flow (current US$) of Denmark in 1999?
Your response must be concise. -3.58e+08. What is the difference between the Aid flow (current US$) of Austria in 1997 and the Aid flow (current US$) of Korea in 1999?
Ensure brevity in your answer.  1.56e+07. What is the difference between the Aid flow (current US$) in Belgium in 1997 and the Aid flow (current US$) in Denmark in 1999?
Your answer should be very brief. -2.42e+08. What is the difference between the Aid flow (current US$) in Belgium in 1997 and the Aid flow (current US$) in Korea in 1999?
Ensure brevity in your answer.  1.31e+08. What is the difference between the Aid flow (current US$) of Denmark in 1997 and the Aid flow (current US$) of Korea in 1999?
Make the answer very short. 3.08e+08. What is the difference between the Aid flow (current US$) in Austria in 1997 and the Aid flow (current US$) in Belgium in 2000?
Your answer should be very brief. -9.75e+07. What is the difference between the Aid flow (current US$) of Austria in 1997 and the Aid flow (current US$) of Denmark in 2000?
Give a very brief answer. -3.17e+08. What is the difference between the Aid flow (current US$) in Austria in 1997 and the Aid flow (current US$) in Korea in 2000?
Keep it short and to the point. 3.12e+07. What is the difference between the Aid flow (current US$) of Belgium in 1997 and the Aid flow (current US$) of Denmark in 2000?
Make the answer very short. -2.02e+08. What is the difference between the Aid flow (current US$) of Belgium in 1997 and the Aid flow (current US$) of Korea in 2000?
Your answer should be very brief. 1.47e+08. What is the difference between the Aid flow (current US$) of Denmark in 1997 and the Aid flow (current US$) of Korea in 2000?
Your answer should be compact. 3.24e+08. What is the difference between the Aid flow (current US$) of Austria in 1998 and the Aid flow (current US$) of Belgium in 1999?
Offer a terse response. -7.05e+07. What is the difference between the Aid flow (current US$) of Austria in 1998 and the Aid flow (current US$) of Denmark in 1999?
Your response must be concise. -3.47e+08. What is the difference between the Aid flow (current US$) in Austria in 1998 and the Aid flow (current US$) in Korea in 1999?
Keep it short and to the point. 2.60e+07. What is the difference between the Aid flow (current US$) in Belgium in 1998 and the Aid flow (current US$) in Denmark in 1999?
Give a very brief answer. -2.19e+08. What is the difference between the Aid flow (current US$) in Belgium in 1998 and the Aid flow (current US$) in Korea in 1999?
Make the answer very short. 1.54e+08. What is the difference between the Aid flow (current US$) in Denmark in 1998 and the Aid flow (current US$) in Korea in 1999?
Make the answer very short. 3.61e+08. What is the difference between the Aid flow (current US$) in Austria in 1998 and the Aid flow (current US$) in Belgium in 2000?
Ensure brevity in your answer.  -8.71e+07. What is the difference between the Aid flow (current US$) of Austria in 1998 and the Aid flow (current US$) of Denmark in 2000?
Offer a terse response. -3.07e+08. What is the difference between the Aid flow (current US$) of Austria in 1998 and the Aid flow (current US$) of Korea in 2000?
Your answer should be compact. 4.16e+07. What is the difference between the Aid flow (current US$) of Belgium in 1998 and the Aid flow (current US$) of Denmark in 2000?
Offer a very short reply. -1.79e+08. What is the difference between the Aid flow (current US$) of Belgium in 1998 and the Aid flow (current US$) of Korea in 2000?
Offer a terse response. 1.70e+08. What is the difference between the Aid flow (current US$) of Denmark in 1998 and the Aid flow (current US$) of Korea in 2000?
Give a very brief answer. 3.77e+08. What is the difference between the Aid flow (current US$) of Austria in 1999 and the Aid flow (current US$) of Belgium in 2000?
Offer a terse response. -1.01e+08. What is the difference between the Aid flow (current US$) of Austria in 1999 and the Aid flow (current US$) of Denmark in 2000?
Give a very brief answer. -3.20e+08. What is the difference between the Aid flow (current US$) of Austria in 1999 and the Aid flow (current US$) of Korea in 2000?
Provide a short and direct response. 2.82e+07. What is the difference between the Aid flow (current US$) of Belgium in 1999 and the Aid flow (current US$) of Denmark in 2000?
Provide a short and direct response. -2.36e+08. What is the difference between the Aid flow (current US$) in Belgium in 1999 and the Aid flow (current US$) in Korea in 2000?
Your answer should be very brief. 1.12e+08. What is the difference between the Aid flow (current US$) of Denmark in 1999 and the Aid flow (current US$) of Korea in 2000?
Ensure brevity in your answer.  3.89e+08. What is the average Aid flow (current US$) in Austria per year?
Provide a short and direct response. 5.29e+07. What is the average Aid flow (current US$) in Belgium per year?
Provide a short and direct response. 1.60e+08. What is the average Aid flow (current US$) of Denmark per year?
Give a very brief answer. 3.51e+08. What is the average Aid flow (current US$) of Korea per year?
Provide a succinct answer. 1.62e+07. In the year 1992, what is the difference between the Aid flow (current US$) of Austria and Aid flow (current US$) of Belgium?
Your response must be concise. -1.51e+08. In the year 1992, what is the difference between the Aid flow (current US$) in Austria and Aid flow (current US$) in Denmark?
Your response must be concise. -2.43e+08. In the year 1992, what is the difference between the Aid flow (current US$) in Austria and Aid flow (current US$) in Korea?
Your answer should be compact. 6.15e+07. In the year 1992, what is the difference between the Aid flow (current US$) in Belgium and Aid flow (current US$) in Denmark?
Give a very brief answer. -9.20e+07. In the year 1992, what is the difference between the Aid flow (current US$) of Belgium and Aid flow (current US$) of Korea?
Your response must be concise. 2.12e+08. In the year 1992, what is the difference between the Aid flow (current US$) of Denmark and Aid flow (current US$) of Korea?
Give a very brief answer. 3.04e+08. In the year 1993, what is the difference between the Aid flow (current US$) in Austria and Aid flow (current US$) in Belgium?
Provide a succinct answer. -1.13e+08. In the year 1993, what is the difference between the Aid flow (current US$) of Austria and Aid flow (current US$) of Denmark?
Your response must be concise. -2.60e+08. In the year 1993, what is the difference between the Aid flow (current US$) of Austria and Aid flow (current US$) of Korea?
Keep it short and to the point. 5.40e+07. In the year 1993, what is the difference between the Aid flow (current US$) in Belgium and Aid flow (current US$) in Denmark?
Your response must be concise. -1.47e+08. In the year 1993, what is the difference between the Aid flow (current US$) of Belgium and Aid flow (current US$) of Korea?
Provide a short and direct response. 1.67e+08. In the year 1993, what is the difference between the Aid flow (current US$) in Denmark and Aid flow (current US$) in Korea?
Give a very brief answer. 3.14e+08. In the year 1994, what is the difference between the Aid flow (current US$) of Austria and Aid flow (current US$) of Belgium?
Your answer should be compact. -9.58e+07. In the year 1994, what is the difference between the Aid flow (current US$) of Austria and Aid flow (current US$) of Denmark?
Provide a succinct answer. -2.65e+08. In the year 1994, what is the difference between the Aid flow (current US$) in Austria and Aid flow (current US$) in Korea?
Offer a terse response. 4.14e+07. In the year 1994, what is the difference between the Aid flow (current US$) in Belgium and Aid flow (current US$) in Denmark?
Provide a succinct answer. -1.69e+08. In the year 1994, what is the difference between the Aid flow (current US$) in Belgium and Aid flow (current US$) in Korea?
Keep it short and to the point. 1.37e+08. In the year 1994, what is the difference between the Aid flow (current US$) in Denmark and Aid flow (current US$) in Korea?
Provide a short and direct response. 3.06e+08. In the year 1995, what is the difference between the Aid flow (current US$) of Austria and Aid flow (current US$) of Belgium?
Your response must be concise. -9.10e+07. In the year 1995, what is the difference between the Aid flow (current US$) in Austria and Aid flow (current US$) in Denmark?
Offer a terse response. -2.70e+08. In the year 1995, what is the difference between the Aid flow (current US$) of Austria and Aid flow (current US$) of Korea?
Your answer should be compact. 4.44e+07. In the year 1995, what is the difference between the Aid flow (current US$) in Belgium and Aid flow (current US$) in Denmark?
Make the answer very short. -1.79e+08. In the year 1995, what is the difference between the Aid flow (current US$) in Belgium and Aid flow (current US$) in Korea?
Offer a terse response. 1.35e+08. In the year 1995, what is the difference between the Aid flow (current US$) of Denmark and Aid flow (current US$) of Korea?
Offer a very short reply. 3.14e+08. In the year 1996, what is the difference between the Aid flow (current US$) of Austria and Aid flow (current US$) of Belgium?
Make the answer very short. -8.86e+07. In the year 1996, what is the difference between the Aid flow (current US$) in Austria and Aid flow (current US$) in Denmark?
Offer a terse response. -3.41e+08. In the year 1996, what is the difference between the Aid flow (current US$) in Austria and Aid flow (current US$) in Korea?
Offer a very short reply. 4.29e+07. In the year 1996, what is the difference between the Aid flow (current US$) of Belgium and Aid flow (current US$) of Denmark?
Provide a short and direct response. -2.52e+08. In the year 1996, what is the difference between the Aid flow (current US$) in Belgium and Aid flow (current US$) in Korea?
Provide a succinct answer. 1.32e+08. In the year 1996, what is the difference between the Aid flow (current US$) of Denmark and Aid flow (current US$) of Korea?
Your response must be concise. 3.83e+08. In the year 1997, what is the difference between the Aid flow (current US$) of Austria and Aid flow (current US$) of Belgium?
Make the answer very short. -1.16e+08. In the year 1997, what is the difference between the Aid flow (current US$) in Austria and Aid flow (current US$) in Denmark?
Provide a short and direct response. -2.92e+08. In the year 1997, what is the difference between the Aid flow (current US$) in Austria and Aid flow (current US$) in Korea?
Make the answer very short. 1.76e+07. In the year 1997, what is the difference between the Aid flow (current US$) of Belgium and Aid flow (current US$) of Denmark?
Provide a short and direct response. -1.77e+08. In the year 1997, what is the difference between the Aid flow (current US$) of Belgium and Aid flow (current US$) of Korea?
Keep it short and to the point. 1.33e+08. In the year 1997, what is the difference between the Aid flow (current US$) of Denmark and Aid flow (current US$) of Korea?
Provide a succinct answer. 3.10e+08. In the year 1998, what is the difference between the Aid flow (current US$) in Austria and Aid flow (current US$) in Belgium?
Provide a short and direct response. -1.28e+08. In the year 1998, what is the difference between the Aid flow (current US$) in Austria and Aid flow (current US$) in Denmark?
Ensure brevity in your answer.  -3.35e+08. In the year 1998, what is the difference between the Aid flow (current US$) in Austria and Aid flow (current US$) in Korea?
Your response must be concise. 2.15e+07. In the year 1998, what is the difference between the Aid flow (current US$) in Belgium and Aid flow (current US$) in Denmark?
Ensure brevity in your answer.  -2.07e+08. In the year 1998, what is the difference between the Aid flow (current US$) of Belgium and Aid flow (current US$) of Korea?
Provide a succinct answer. 1.49e+08. In the year 1998, what is the difference between the Aid flow (current US$) of Denmark and Aid flow (current US$) of Korea?
Make the answer very short. 3.56e+08. In the year 1999, what is the difference between the Aid flow (current US$) of Austria and Aid flow (current US$) of Belgium?
Provide a short and direct response. -8.40e+07. In the year 1999, what is the difference between the Aid flow (current US$) in Austria and Aid flow (current US$) in Denmark?
Your answer should be compact. -3.61e+08. In the year 1999, what is the difference between the Aid flow (current US$) in Austria and Aid flow (current US$) in Korea?
Give a very brief answer. 1.25e+07. In the year 1999, what is the difference between the Aid flow (current US$) of Belgium and Aid flow (current US$) of Denmark?
Offer a terse response. -2.77e+08. In the year 1999, what is the difference between the Aid flow (current US$) of Belgium and Aid flow (current US$) of Korea?
Give a very brief answer. 9.65e+07. In the year 1999, what is the difference between the Aid flow (current US$) of Denmark and Aid flow (current US$) of Korea?
Your answer should be very brief. 3.73e+08. In the year 2000, what is the difference between the Aid flow (current US$) in Austria and Aid flow (current US$) in Belgium?
Your answer should be compact. -9.37e+07. In the year 2000, what is the difference between the Aid flow (current US$) of Austria and Aid flow (current US$) of Denmark?
Your answer should be very brief. -3.14e+08. In the year 2000, what is the difference between the Aid flow (current US$) of Austria and Aid flow (current US$) of Korea?
Make the answer very short. 3.50e+07. In the year 2000, what is the difference between the Aid flow (current US$) in Belgium and Aid flow (current US$) in Denmark?
Provide a succinct answer. -2.20e+08. In the year 2000, what is the difference between the Aid flow (current US$) in Belgium and Aid flow (current US$) in Korea?
Provide a succinct answer. 1.29e+08. In the year 2000, what is the difference between the Aid flow (current US$) in Denmark and Aid flow (current US$) in Korea?
Ensure brevity in your answer.  3.49e+08. What is the ratio of the Aid flow (current US$) of Austria in 1992 to that in 1993?
Provide a short and direct response. 1.11. What is the ratio of the Aid flow (current US$) in Belgium in 1992 to that in 1993?
Your response must be concise. 1.26. What is the ratio of the Aid flow (current US$) of Denmark in 1992 to that in 1993?
Your answer should be very brief. 0.97. What is the ratio of the Aid flow (current US$) of Korea in 1992 to that in 1993?
Offer a very short reply. 0.79. What is the ratio of the Aid flow (current US$) in Austria in 1992 to that in 1994?
Your answer should be compact. 1.16. What is the ratio of the Aid flow (current US$) in Belgium in 1992 to that in 1994?
Offer a terse response. 1.42. What is the ratio of the Aid flow (current US$) in Denmark in 1992 to that in 1994?
Give a very brief answer. 0.96. What is the ratio of the Aid flow (current US$) of Korea in 1992 to that in 1994?
Ensure brevity in your answer.  0.27. What is the ratio of the Aid flow (current US$) of Austria in 1992 to that in 1995?
Keep it short and to the point. 1.11. What is the ratio of the Aid flow (current US$) of Belgium in 1992 to that in 1995?
Make the answer very short. 1.44. What is the ratio of the Aid flow (current US$) of Denmark in 1992 to that in 1995?
Keep it short and to the point. 0.94. What is the ratio of the Aid flow (current US$) of Korea in 1992 to that in 1995?
Provide a succinct answer. 0.27. What is the ratio of the Aid flow (current US$) in Austria in 1992 to that in 1996?
Offer a terse response. 1.18. What is the ratio of the Aid flow (current US$) of Belgium in 1992 to that in 1996?
Your response must be concise. 1.5. What is the ratio of the Aid flow (current US$) of Denmark in 1992 to that in 1996?
Your response must be concise. 0.78. What is the ratio of the Aid flow (current US$) in Korea in 1992 to that in 1996?
Your answer should be compact. 0.31. What is the ratio of the Aid flow (current US$) in Austria in 1992 to that in 1997?
Your response must be concise. 1.55. What is the ratio of the Aid flow (current US$) in Belgium in 1992 to that in 1997?
Your answer should be very brief. 1.37. What is the ratio of the Aid flow (current US$) of Denmark in 1992 to that in 1997?
Keep it short and to the point. 0.92. What is the ratio of the Aid flow (current US$) in Korea in 1992 to that in 1997?
Provide a short and direct response. 0.16. What is the ratio of the Aid flow (current US$) in Austria in 1992 to that in 1998?
Keep it short and to the point. 1.24. What is the ratio of the Aid flow (current US$) of Belgium in 1992 to that in 1998?
Your answer should be very brief. 1.2. What is the ratio of the Aid flow (current US$) in Denmark in 1992 to that in 1998?
Offer a terse response. 0.8. What is the ratio of the Aid flow (current US$) of Korea in 1992 to that in 1998?
Your answer should be very brief. 0.13. What is the ratio of the Aid flow (current US$) in Austria in 1992 to that in 1999?
Make the answer very short. 1.67. What is the ratio of the Aid flow (current US$) of Belgium in 1992 to that in 1999?
Ensure brevity in your answer.  1.76. What is the ratio of the Aid flow (current US$) in Denmark in 1992 to that in 1999?
Give a very brief answer. 0.77. What is the ratio of the Aid flow (current US$) of Austria in 1992 to that in 2000?
Your response must be concise. 1.42. What is the ratio of the Aid flow (current US$) in Belgium in 1992 to that in 2000?
Offer a terse response. 1.55. What is the ratio of the Aid flow (current US$) in Denmark in 1992 to that in 2000?
Your response must be concise. 0.86. What is the ratio of the Aid flow (current US$) of Korea in 1992 to that in 2000?
Offer a very short reply. 0.36. What is the ratio of the Aid flow (current US$) of Austria in 1993 to that in 1994?
Provide a short and direct response. 1.05. What is the ratio of the Aid flow (current US$) in Belgium in 1993 to that in 1994?
Your answer should be compact. 1.13. What is the ratio of the Aid flow (current US$) of Denmark in 1993 to that in 1994?
Offer a very short reply. 0.99. What is the ratio of the Aid flow (current US$) of Korea in 1993 to that in 1994?
Provide a short and direct response. 0.34. What is the ratio of the Aid flow (current US$) of Austria in 1993 to that in 1995?
Provide a short and direct response. 1. What is the ratio of the Aid flow (current US$) in Belgium in 1993 to that in 1995?
Your answer should be very brief. 1.14. What is the ratio of the Aid flow (current US$) of Denmark in 1993 to that in 1995?
Your response must be concise. 0.97. What is the ratio of the Aid flow (current US$) in Korea in 1993 to that in 1995?
Ensure brevity in your answer.  0.35. What is the ratio of the Aid flow (current US$) in Austria in 1993 to that in 1996?
Make the answer very short. 1.06. What is the ratio of the Aid flow (current US$) in Belgium in 1993 to that in 1996?
Provide a short and direct response. 1.19. What is the ratio of the Aid flow (current US$) of Denmark in 1993 to that in 1996?
Your answer should be compact. 0.8. What is the ratio of the Aid flow (current US$) in Korea in 1993 to that in 1996?
Your response must be concise. 0.4. What is the ratio of the Aid flow (current US$) of Austria in 1993 to that in 1997?
Your answer should be compact. 1.4. What is the ratio of the Aid flow (current US$) in Belgium in 1993 to that in 1997?
Ensure brevity in your answer.  1.09. What is the ratio of the Aid flow (current US$) of Denmark in 1993 to that in 1997?
Ensure brevity in your answer.  0.95. What is the ratio of the Aid flow (current US$) in Korea in 1993 to that in 1997?
Provide a succinct answer. 0.21. What is the ratio of the Aid flow (current US$) of Austria in 1993 to that in 1998?
Give a very brief answer. 1.12. What is the ratio of the Aid flow (current US$) in Belgium in 1993 to that in 1998?
Your answer should be very brief. 0.95. What is the ratio of the Aid flow (current US$) of Denmark in 1993 to that in 1998?
Give a very brief answer. 0.82. What is the ratio of the Aid flow (current US$) in Korea in 1993 to that in 1998?
Provide a short and direct response. 0.16. What is the ratio of the Aid flow (current US$) of Austria in 1993 to that in 1999?
Make the answer very short. 1.51. What is the ratio of the Aid flow (current US$) in Belgium in 1993 to that in 1999?
Your answer should be very brief. 1.39. What is the ratio of the Aid flow (current US$) in Denmark in 1993 to that in 1999?
Provide a succinct answer. 0.8. What is the ratio of the Aid flow (current US$) of Korea in 1993 to that in 1999?
Provide a short and direct response. 0.19. What is the ratio of the Aid flow (current US$) in Austria in 1993 to that in 2000?
Make the answer very short. 1.28. What is the ratio of the Aid flow (current US$) of Belgium in 1993 to that in 2000?
Offer a terse response. 1.23. What is the ratio of the Aid flow (current US$) in Denmark in 1993 to that in 2000?
Ensure brevity in your answer.  0.89. What is the ratio of the Aid flow (current US$) in Korea in 1993 to that in 2000?
Offer a very short reply. 0.46. What is the ratio of the Aid flow (current US$) of Austria in 1994 to that in 1995?
Keep it short and to the point. 0.96. What is the ratio of the Aid flow (current US$) of Belgium in 1994 to that in 1995?
Provide a short and direct response. 1.02. What is the ratio of the Aid flow (current US$) in Denmark in 1994 to that in 1995?
Offer a very short reply. 0.98. What is the ratio of the Aid flow (current US$) of Korea in 1994 to that in 1995?
Provide a short and direct response. 1.03. What is the ratio of the Aid flow (current US$) in Austria in 1994 to that in 1996?
Your answer should be very brief. 1.01. What is the ratio of the Aid flow (current US$) of Belgium in 1994 to that in 1996?
Give a very brief answer. 1.05. What is the ratio of the Aid flow (current US$) of Denmark in 1994 to that in 1996?
Your answer should be compact. 0.81. What is the ratio of the Aid flow (current US$) in Korea in 1994 to that in 1996?
Your answer should be very brief. 1.18. What is the ratio of the Aid flow (current US$) in Austria in 1994 to that in 1997?
Make the answer very short. 1.33. What is the ratio of the Aid flow (current US$) of Belgium in 1994 to that in 1997?
Ensure brevity in your answer.  0.96. What is the ratio of the Aid flow (current US$) of Denmark in 1994 to that in 1997?
Your answer should be compact. 0.96. What is the ratio of the Aid flow (current US$) of Korea in 1994 to that in 1997?
Provide a succinct answer. 0.61. What is the ratio of the Aid flow (current US$) in Austria in 1994 to that in 1998?
Offer a terse response. 1.07. What is the ratio of the Aid flow (current US$) of Belgium in 1994 to that in 1998?
Your response must be concise. 0.84. What is the ratio of the Aid flow (current US$) in Denmark in 1994 to that in 1998?
Offer a terse response. 0.83. What is the ratio of the Aid flow (current US$) of Korea in 1994 to that in 1998?
Your response must be concise. 0.48. What is the ratio of the Aid flow (current US$) in Austria in 1994 to that in 1999?
Keep it short and to the point. 1.44. What is the ratio of the Aid flow (current US$) of Belgium in 1994 to that in 1999?
Provide a short and direct response. 1.24. What is the ratio of the Aid flow (current US$) in Denmark in 1994 to that in 1999?
Ensure brevity in your answer.  0.8. What is the ratio of the Aid flow (current US$) of Korea in 1994 to that in 1999?
Ensure brevity in your answer.  0.56. What is the ratio of the Aid flow (current US$) of Austria in 1994 to that in 2000?
Your answer should be very brief. 1.23. What is the ratio of the Aid flow (current US$) of Belgium in 1994 to that in 2000?
Provide a short and direct response. 1.09. What is the ratio of the Aid flow (current US$) in Denmark in 1994 to that in 2000?
Give a very brief answer. 0.89. What is the ratio of the Aid flow (current US$) in Korea in 1994 to that in 2000?
Offer a very short reply. 1.36. What is the ratio of the Aid flow (current US$) of Austria in 1995 to that in 1996?
Make the answer very short. 1.06. What is the ratio of the Aid flow (current US$) in Belgium in 1995 to that in 1996?
Offer a terse response. 1.04. What is the ratio of the Aid flow (current US$) of Denmark in 1995 to that in 1996?
Give a very brief answer. 0.83. What is the ratio of the Aid flow (current US$) of Korea in 1995 to that in 1996?
Offer a terse response. 1.14. What is the ratio of the Aid flow (current US$) in Austria in 1995 to that in 1997?
Keep it short and to the point. 1.4. What is the ratio of the Aid flow (current US$) in Belgium in 1995 to that in 1997?
Your answer should be compact. 0.95. What is the ratio of the Aid flow (current US$) of Denmark in 1995 to that in 1997?
Provide a short and direct response. 0.98. What is the ratio of the Aid flow (current US$) in Korea in 1995 to that in 1997?
Your answer should be compact. 0.59. What is the ratio of the Aid flow (current US$) in Austria in 1995 to that in 1998?
Offer a very short reply. 1.12. What is the ratio of the Aid flow (current US$) in Belgium in 1995 to that in 1998?
Offer a very short reply. 0.83. What is the ratio of the Aid flow (current US$) of Denmark in 1995 to that in 1998?
Your response must be concise. 0.85. What is the ratio of the Aid flow (current US$) of Korea in 1995 to that in 1998?
Your answer should be compact. 0.47. What is the ratio of the Aid flow (current US$) in Austria in 1995 to that in 1999?
Keep it short and to the point. 1.5. What is the ratio of the Aid flow (current US$) in Belgium in 1995 to that in 1999?
Offer a terse response. 1.22. What is the ratio of the Aid flow (current US$) in Denmark in 1995 to that in 1999?
Offer a very short reply. 0.82. What is the ratio of the Aid flow (current US$) in Korea in 1995 to that in 1999?
Your answer should be very brief. 0.55. What is the ratio of the Aid flow (current US$) of Austria in 1995 to that in 2000?
Offer a terse response. 1.28. What is the ratio of the Aid flow (current US$) in Belgium in 1995 to that in 2000?
Your answer should be compact. 1.07. What is the ratio of the Aid flow (current US$) in Denmark in 1995 to that in 2000?
Keep it short and to the point. 0.91. What is the ratio of the Aid flow (current US$) in Korea in 1995 to that in 2000?
Provide a succinct answer. 1.32. What is the ratio of the Aid flow (current US$) in Austria in 1996 to that in 1997?
Provide a succinct answer. 1.32. What is the ratio of the Aid flow (current US$) of Belgium in 1996 to that in 1997?
Your answer should be compact. 0.91. What is the ratio of the Aid flow (current US$) of Denmark in 1996 to that in 1997?
Offer a very short reply. 1.18. What is the ratio of the Aid flow (current US$) of Korea in 1996 to that in 1997?
Give a very brief answer. 0.52. What is the ratio of the Aid flow (current US$) in Austria in 1996 to that in 1998?
Offer a terse response. 1.06. What is the ratio of the Aid flow (current US$) in Belgium in 1996 to that in 1998?
Keep it short and to the point. 0.8. What is the ratio of the Aid flow (current US$) in Denmark in 1996 to that in 1998?
Your answer should be very brief. 1.02. What is the ratio of the Aid flow (current US$) in Korea in 1996 to that in 1998?
Give a very brief answer. 0.41. What is the ratio of the Aid flow (current US$) in Austria in 1996 to that in 1999?
Offer a very short reply. 1.42. What is the ratio of the Aid flow (current US$) in Belgium in 1996 to that in 1999?
Your answer should be compact. 1.17. What is the ratio of the Aid flow (current US$) in Denmark in 1996 to that in 1999?
Give a very brief answer. 0.99. What is the ratio of the Aid flow (current US$) in Korea in 1996 to that in 1999?
Provide a succinct answer. 0.48. What is the ratio of the Aid flow (current US$) of Austria in 1996 to that in 2000?
Ensure brevity in your answer.  1.21. What is the ratio of the Aid flow (current US$) in Belgium in 1996 to that in 2000?
Provide a succinct answer. 1.03. What is the ratio of the Aid flow (current US$) of Denmark in 1996 to that in 2000?
Provide a short and direct response. 1.1. What is the ratio of the Aid flow (current US$) in Korea in 1996 to that in 2000?
Keep it short and to the point. 1.16. What is the ratio of the Aid flow (current US$) of Austria in 1997 to that in 1998?
Give a very brief answer. 0.8. What is the ratio of the Aid flow (current US$) in Belgium in 1997 to that in 1998?
Give a very brief answer. 0.87. What is the ratio of the Aid flow (current US$) in Denmark in 1997 to that in 1998?
Offer a terse response. 0.86. What is the ratio of the Aid flow (current US$) of Korea in 1997 to that in 1998?
Your answer should be very brief. 0.79. What is the ratio of the Aid flow (current US$) of Austria in 1997 to that in 1999?
Ensure brevity in your answer.  1.08. What is the ratio of the Aid flow (current US$) in Belgium in 1997 to that in 1999?
Offer a terse response. 1.28. What is the ratio of the Aid flow (current US$) of Denmark in 1997 to that in 1999?
Offer a terse response. 0.84. What is the ratio of the Aid flow (current US$) of Korea in 1997 to that in 1999?
Your response must be concise. 0.92. What is the ratio of the Aid flow (current US$) in Austria in 1997 to that in 2000?
Ensure brevity in your answer.  0.92. What is the ratio of the Aid flow (current US$) of Belgium in 1997 to that in 2000?
Give a very brief answer. 1.13. What is the ratio of the Aid flow (current US$) in Denmark in 1997 to that in 2000?
Offer a very short reply. 0.93. What is the ratio of the Aid flow (current US$) in Korea in 1997 to that in 2000?
Ensure brevity in your answer.  2.23. What is the ratio of the Aid flow (current US$) of Austria in 1998 to that in 1999?
Offer a terse response. 1.34. What is the ratio of the Aid flow (current US$) in Belgium in 1998 to that in 1999?
Your answer should be compact. 1.47. What is the ratio of the Aid flow (current US$) in Denmark in 1998 to that in 1999?
Your answer should be very brief. 0.97. What is the ratio of the Aid flow (current US$) in Korea in 1998 to that in 1999?
Make the answer very short. 1.17. What is the ratio of the Aid flow (current US$) of Austria in 1998 to that in 2000?
Give a very brief answer. 1.14. What is the ratio of the Aid flow (current US$) of Belgium in 1998 to that in 2000?
Offer a very short reply. 1.29. What is the ratio of the Aid flow (current US$) in Denmark in 1998 to that in 2000?
Your answer should be compact. 1.08. What is the ratio of the Aid flow (current US$) of Korea in 1998 to that in 2000?
Make the answer very short. 2.82. What is the ratio of the Aid flow (current US$) in Austria in 1999 to that in 2000?
Provide a short and direct response. 0.85. What is the ratio of the Aid flow (current US$) of Belgium in 1999 to that in 2000?
Your answer should be very brief. 0.88. What is the ratio of the Aid flow (current US$) of Denmark in 1999 to that in 2000?
Your response must be concise. 1.11. What is the ratio of the Aid flow (current US$) in Korea in 1999 to that in 2000?
Provide a short and direct response. 2.41. What is the difference between the highest and the second highest Aid flow (current US$) of Austria?
Your answer should be very brief. 6.38e+06. What is the difference between the highest and the second highest Aid flow (current US$) of Belgium?
Your answer should be compact. 3.58e+07. What is the difference between the highest and the second highest Aid flow (current US$) of Denmark?
Provide a succinct answer. 3.70e+06. What is the difference between the highest and the second highest Aid flow (current US$) of Korea?
Your response must be concise. 4.51e+06. What is the difference between the highest and the lowest Aid flow (current US$) of Austria?
Provide a succinct answer. 2.63e+07. What is the difference between the highest and the lowest Aid flow (current US$) of Belgium?
Give a very brief answer. 9.32e+07. What is the difference between the highest and the lowest Aid flow (current US$) of Denmark?
Keep it short and to the point. 9.15e+07. What is the difference between the highest and the lowest Aid flow (current US$) of Korea?
Provide a succinct answer. 2.72e+07. 